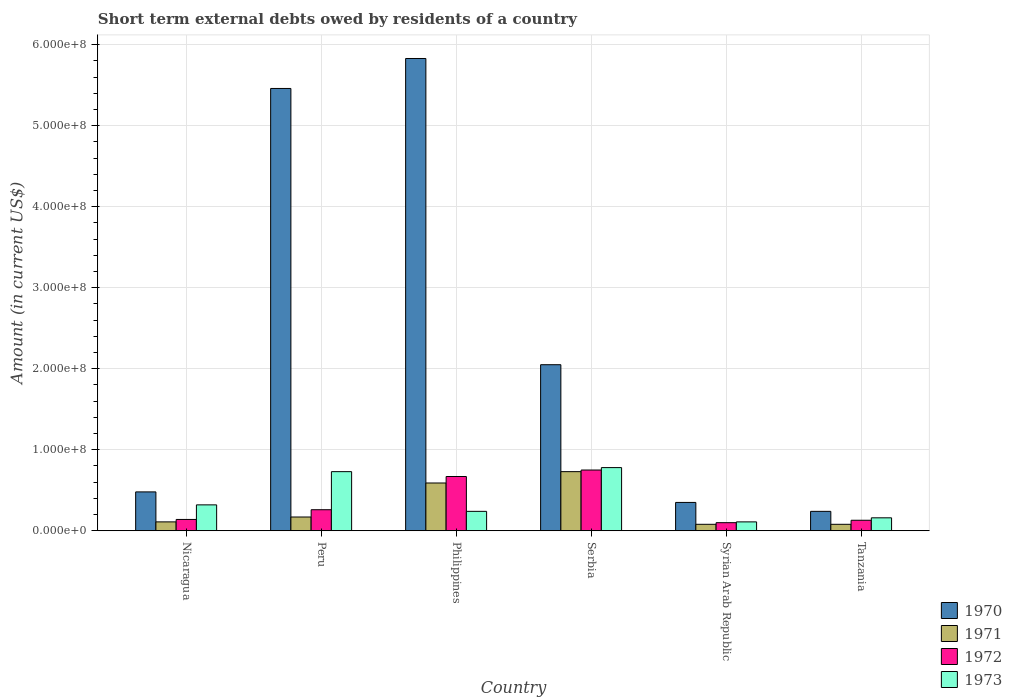How many groups of bars are there?
Keep it short and to the point. 6. Are the number of bars on each tick of the X-axis equal?
Your answer should be compact. Yes. How many bars are there on the 4th tick from the left?
Ensure brevity in your answer.  4. What is the label of the 6th group of bars from the left?
Keep it short and to the point. Tanzania. Across all countries, what is the maximum amount of short-term external debts owed by residents in 1972?
Provide a succinct answer. 7.50e+07. Across all countries, what is the minimum amount of short-term external debts owed by residents in 1973?
Your response must be concise. 1.10e+07. In which country was the amount of short-term external debts owed by residents in 1971 maximum?
Your answer should be very brief. Serbia. In which country was the amount of short-term external debts owed by residents in 1971 minimum?
Offer a very short reply. Syrian Arab Republic. What is the total amount of short-term external debts owed by residents in 1972 in the graph?
Your response must be concise. 2.05e+08. What is the difference between the amount of short-term external debts owed by residents in 1973 in Philippines and that in Serbia?
Ensure brevity in your answer.  -5.40e+07. What is the difference between the amount of short-term external debts owed by residents in 1970 in Nicaragua and the amount of short-term external debts owed by residents in 1971 in Tanzania?
Your answer should be very brief. 4.00e+07. What is the average amount of short-term external debts owed by residents in 1971 per country?
Give a very brief answer. 2.93e+07. What is the difference between the amount of short-term external debts owed by residents of/in 1971 and amount of short-term external debts owed by residents of/in 1972 in Nicaragua?
Make the answer very short. -3.00e+06. What is the ratio of the amount of short-term external debts owed by residents in 1973 in Philippines to that in Tanzania?
Offer a very short reply. 1.5. What is the difference between the highest and the second highest amount of short-term external debts owed by residents in 1972?
Your answer should be compact. 4.90e+07. What is the difference between the highest and the lowest amount of short-term external debts owed by residents in 1971?
Make the answer very short. 6.50e+07. In how many countries, is the amount of short-term external debts owed by residents in 1971 greater than the average amount of short-term external debts owed by residents in 1971 taken over all countries?
Your response must be concise. 2. What does the 3rd bar from the left in Tanzania represents?
Ensure brevity in your answer.  1972. How many bars are there?
Your answer should be very brief. 24. Are all the bars in the graph horizontal?
Offer a terse response. No. What is the difference between two consecutive major ticks on the Y-axis?
Give a very brief answer. 1.00e+08. Are the values on the major ticks of Y-axis written in scientific E-notation?
Keep it short and to the point. Yes. Does the graph contain any zero values?
Give a very brief answer. No. What is the title of the graph?
Provide a short and direct response. Short term external debts owed by residents of a country. Does "1979" appear as one of the legend labels in the graph?
Offer a very short reply. No. What is the label or title of the X-axis?
Offer a terse response. Country. What is the Amount (in current US$) in 1970 in Nicaragua?
Offer a terse response. 4.80e+07. What is the Amount (in current US$) of 1971 in Nicaragua?
Your response must be concise. 1.10e+07. What is the Amount (in current US$) of 1972 in Nicaragua?
Keep it short and to the point. 1.40e+07. What is the Amount (in current US$) of 1973 in Nicaragua?
Your answer should be very brief. 3.20e+07. What is the Amount (in current US$) in 1970 in Peru?
Keep it short and to the point. 5.46e+08. What is the Amount (in current US$) of 1971 in Peru?
Provide a succinct answer. 1.70e+07. What is the Amount (in current US$) of 1972 in Peru?
Provide a short and direct response. 2.60e+07. What is the Amount (in current US$) of 1973 in Peru?
Your answer should be very brief. 7.30e+07. What is the Amount (in current US$) in 1970 in Philippines?
Ensure brevity in your answer.  5.83e+08. What is the Amount (in current US$) in 1971 in Philippines?
Offer a terse response. 5.90e+07. What is the Amount (in current US$) of 1972 in Philippines?
Keep it short and to the point. 6.70e+07. What is the Amount (in current US$) of 1973 in Philippines?
Keep it short and to the point. 2.40e+07. What is the Amount (in current US$) in 1970 in Serbia?
Offer a very short reply. 2.05e+08. What is the Amount (in current US$) in 1971 in Serbia?
Give a very brief answer. 7.30e+07. What is the Amount (in current US$) of 1972 in Serbia?
Make the answer very short. 7.50e+07. What is the Amount (in current US$) of 1973 in Serbia?
Provide a succinct answer. 7.80e+07. What is the Amount (in current US$) of 1970 in Syrian Arab Republic?
Offer a terse response. 3.50e+07. What is the Amount (in current US$) of 1971 in Syrian Arab Republic?
Ensure brevity in your answer.  8.00e+06. What is the Amount (in current US$) in 1972 in Syrian Arab Republic?
Provide a short and direct response. 1.00e+07. What is the Amount (in current US$) in 1973 in Syrian Arab Republic?
Ensure brevity in your answer.  1.10e+07. What is the Amount (in current US$) in 1970 in Tanzania?
Your answer should be very brief. 2.40e+07. What is the Amount (in current US$) in 1971 in Tanzania?
Make the answer very short. 8.00e+06. What is the Amount (in current US$) of 1972 in Tanzania?
Offer a very short reply. 1.30e+07. What is the Amount (in current US$) of 1973 in Tanzania?
Offer a very short reply. 1.60e+07. Across all countries, what is the maximum Amount (in current US$) of 1970?
Your response must be concise. 5.83e+08. Across all countries, what is the maximum Amount (in current US$) in 1971?
Offer a terse response. 7.30e+07. Across all countries, what is the maximum Amount (in current US$) of 1972?
Make the answer very short. 7.50e+07. Across all countries, what is the maximum Amount (in current US$) in 1973?
Keep it short and to the point. 7.80e+07. Across all countries, what is the minimum Amount (in current US$) of 1970?
Give a very brief answer. 2.40e+07. Across all countries, what is the minimum Amount (in current US$) in 1973?
Offer a terse response. 1.10e+07. What is the total Amount (in current US$) in 1970 in the graph?
Your answer should be very brief. 1.44e+09. What is the total Amount (in current US$) in 1971 in the graph?
Make the answer very short. 1.76e+08. What is the total Amount (in current US$) of 1972 in the graph?
Offer a terse response. 2.05e+08. What is the total Amount (in current US$) of 1973 in the graph?
Offer a very short reply. 2.34e+08. What is the difference between the Amount (in current US$) in 1970 in Nicaragua and that in Peru?
Make the answer very short. -4.98e+08. What is the difference between the Amount (in current US$) of 1971 in Nicaragua and that in Peru?
Give a very brief answer. -6.00e+06. What is the difference between the Amount (in current US$) of 1972 in Nicaragua and that in Peru?
Offer a terse response. -1.20e+07. What is the difference between the Amount (in current US$) in 1973 in Nicaragua and that in Peru?
Provide a succinct answer. -4.10e+07. What is the difference between the Amount (in current US$) in 1970 in Nicaragua and that in Philippines?
Ensure brevity in your answer.  -5.35e+08. What is the difference between the Amount (in current US$) of 1971 in Nicaragua and that in Philippines?
Your answer should be compact. -4.80e+07. What is the difference between the Amount (in current US$) of 1972 in Nicaragua and that in Philippines?
Offer a terse response. -5.30e+07. What is the difference between the Amount (in current US$) in 1973 in Nicaragua and that in Philippines?
Ensure brevity in your answer.  8.00e+06. What is the difference between the Amount (in current US$) in 1970 in Nicaragua and that in Serbia?
Offer a terse response. -1.57e+08. What is the difference between the Amount (in current US$) in 1971 in Nicaragua and that in Serbia?
Your answer should be very brief. -6.20e+07. What is the difference between the Amount (in current US$) of 1972 in Nicaragua and that in Serbia?
Offer a very short reply. -6.10e+07. What is the difference between the Amount (in current US$) of 1973 in Nicaragua and that in Serbia?
Provide a succinct answer. -4.60e+07. What is the difference between the Amount (in current US$) of 1970 in Nicaragua and that in Syrian Arab Republic?
Your answer should be compact. 1.30e+07. What is the difference between the Amount (in current US$) in 1971 in Nicaragua and that in Syrian Arab Republic?
Offer a very short reply. 3.00e+06. What is the difference between the Amount (in current US$) in 1972 in Nicaragua and that in Syrian Arab Republic?
Provide a succinct answer. 4.00e+06. What is the difference between the Amount (in current US$) in 1973 in Nicaragua and that in Syrian Arab Republic?
Provide a short and direct response. 2.10e+07. What is the difference between the Amount (in current US$) in 1970 in Nicaragua and that in Tanzania?
Provide a short and direct response. 2.40e+07. What is the difference between the Amount (in current US$) in 1971 in Nicaragua and that in Tanzania?
Offer a very short reply. 3.00e+06. What is the difference between the Amount (in current US$) of 1973 in Nicaragua and that in Tanzania?
Your answer should be compact. 1.60e+07. What is the difference between the Amount (in current US$) in 1970 in Peru and that in Philippines?
Offer a very short reply. -3.70e+07. What is the difference between the Amount (in current US$) in 1971 in Peru and that in Philippines?
Your answer should be compact. -4.20e+07. What is the difference between the Amount (in current US$) of 1972 in Peru and that in Philippines?
Your response must be concise. -4.10e+07. What is the difference between the Amount (in current US$) of 1973 in Peru and that in Philippines?
Ensure brevity in your answer.  4.90e+07. What is the difference between the Amount (in current US$) in 1970 in Peru and that in Serbia?
Your response must be concise. 3.41e+08. What is the difference between the Amount (in current US$) in 1971 in Peru and that in Serbia?
Offer a terse response. -5.60e+07. What is the difference between the Amount (in current US$) of 1972 in Peru and that in Serbia?
Provide a short and direct response. -4.90e+07. What is the difference between the Amount (in current US$) of 1973 in Peru and that in Serbia?
Your response must be concise. -5.00e+06. What is the difference between the Amount (in current US$) in 1970 in Peru and that in Syrian Arab Republic?
Your answer should be very brief. 5.11e+08. What is the difference between the Amount (in current US$) in 1971 in Peru and that in Syrian Arab Republic?
Offer a very short reply. 9.00e+06. What is the difference between the Amount (in current US$) of 1972 in Peru and that in Syrian Arab Republic?
Your answer should be very brief. 1.60e+07. What is the difference between the Amount (in current US$) of 1973 in Peru and that in Syrian Arab Republic?
Provide a short and direct response. 6.20e+07. What is the difference between the Amount (in current US$) of 1970 in Peru and that in Tanzania?
Provide a succinct answer. 5.22e+08. What is the difference between the Amount (in current US$) of 1971 in Peru and that in Tanzania?
Your answer should be very brief. 9.00e+06. What is the difference between the Amount (in current US$) in 1972 in Peru and that in Tanzania?
Your response must be concise. 1.30e+07. What is the difference between the Amount (in current US$) of 1973 in Peru and that in Tanzania?
Keep it short and to the point. 5.70e+07. What is the difference between the Amount (in current US$) of 1970 in Philippines and that in Serbia?
Provide a short and direct response. 3.78e+08. What is the difference between the Amount (in current US$) of 1971 in Philippines and that in Serbia?
Provide a short and direct response. -1.40e+07. What is the difference between the Amount (in current US$) of 1972 in Philippines and that in Serbia?
Offer a terse response. -8.00e+06. What is the difference between the Amount (in current US$) in 1973 in Philippines and that in Serbia?
Give a very brief answer. -5.40e+07. What is the difference between the Amount (in current US$) of 1970 in Philippines and that in Syrian Arab Republic?
Provide a succinct answer. 5.48e+08. What is the difference between the Amount (in current US$) of 1971 in Philippines and that in Syrian Arab Republic?
Provide a short and direct response. 5.10e+07. What is the difference between the Amount (in current US$) in 1972 in Philippines and that in Syrian Arab Republic?
Offer a terse response. 5.70e+07. What is the difference between the Amount (in current US$) of 1973 in Philippines and that in Syrian Arab Republic?
Provide a succinct answer. 1.30e+07. What is the difference between the Amount (in current US$) of 1970 in Philippines and that in Tanzania?
Your answer should be very brief. 5.59e+08. What is the difference between the Amount (in current US$) in 1971 in Philippines and that in Tanzania?
Your response must be concise. 5.10e+07. What is the difference between the Amount (in current US$) in 1972 in Philippines and that in Tanzania?
Your response must be concise. 5.40e+07. What is the difference between the Amount (in current US$) of 1973 in Philippines and that in Tanzania?
Provide a succinct answer. 8.00e+06. What is the difference between the Amount (in current US$) of 1970 in Serbia and that in Syrian Arab Republic?
Your answer should be very brief. 1.70e+08. What is the difference between the Amount (in current US$) in 1971 in Serbia and that in Syrian Arab Republic?
Provide a short and direct response. 6.50e+07. What is the difference between the Amount (in current US$) in 1972 in Serbia and that in Syrian Arab Republic?
Keep it short and to the point. 6.50e+07. What is the difference between the Amount (in current US$) of 1973 in Serbia and that in Syrian Arab Republic?
Ensure brevity in your answer.  6.70e+07. What is the difference between the Amount (in current US$) of 1970 in Serbia and that in Tanzania?
Your response must be concise. 1.81e+08. What is the difference between the Amount (in current US$) of 1971 in Serbia and that in Tanzania?
Provide a succinct answer. 6.50e+07. What is the difference between the Amount (in current US$) in 1972 in Serbia and that in Tanzania?
Keep it short and to the point. 6.20e+07. What is the difference between the Amount (in current US$) of 1973 in Serbia and that in Tanzania?
Make the answer very short. 6.20e+07. What is the difference between the Amount (in current US$) of 1970 in Syrian Arab Republic and that in Tanzania?
Provide a short and direct response. 1.10e+07. What is the difference between the Amount (in current US$) of 1971 in Syrian Arab Republic and that in Tanzania?
Your response must be concise. 0. What is the difference between the Amount (in current US$) in 1972 in Syrian Arab Republic and that in Tanzania?
Keep it short and to the point. -3.00e+06. What is the difference between the Amount (in current US$) of 1973 in Syrian Arab Republic and that in Tanzania?
Your answer should be very brief. -5.00e+06. What is the difference between the Amount (in current US$) in 1970 in Nicaragua and the Amount (in current US$) in 1971 in Peru?
Your answer should be very brief. 3.10e+07. What is the difference between the Amount (in current US$) of 1970 in Nicaragua and the Amount (in current US$) of 1972 in Peru?
Keep it short and to the point. 2.20e+07. What is the difference between the Amount (in current US$) of 1970 in Nicaragua and the Amount (in current US$) of 1973 in Peru?
Ensure brevity in your answer.  -2.50e+07. What is the difference between the Amount (in current US$) of 1971 in Nicaragua and the Amount (in current US$) of 1972 in Peru?
Offer a very short reply. -1.50e+07. What is the difference between the Amount (in current US$) of 1971 in Nicaragua and the Amount (in current US$) of 1973 in Peru?
Give a very brief answer. -6.20e+07. What is the difference between the Amount (in current US$) in 1972 in Nicaragua and the Amount (in current US$) in 1973 in Peru?
Make the answer very short. -5.90e+07. What is the difference between the Amount (in current US$) in 1970 in Nicaragua and the Amount (in current US$) in 1971 in Philippines?
Your response must be concise. -1.10e+07. What is the difference between the Amount (in current US$) in 1970 in Nicaragua and the Amount (in current US$) in 1972 in Philippines?
Keep it short and to the point. -1.90e+07. What is the difference between the Amount (in current US$) of 1970 in Nicaragua and the Amount (in current US$) of 1973 in Philippines?
Offer a terse response. 2.40e+07. What is the difference between the Amount (in current US$) in 1971 in Nicaragua and the Amount (in current US$) in 1972 in Philippines?
Ensure brevity in your answer.  -5.60e+07. What is the difference between the Amount (in current US$) in 1971 in Nicaragua and the Amount (in current US$) in 1973 in Philippines?
Your answer should be compact. -1.30e+07. What is the difference between the Amount (in current US$) of 1972 in Nicaragua and the Amount (in current US$) of 1973 in Philippines?
Give a very brief answer. -1.00e+07. What is the difference between the Amount (in current US$) of 1970 in Nicaragua and the Amount (in current US$) of 1971 in Serbia?
Your answer should be compact. -2.50e+07. What is the difference between the Amount (in current US$) of 1970 in Nicaragua and the Amount (in current US$) of 1972 in Serbia?
Your response must be concise. -2.70e+07. What is the difference between the Amount (in current US$) in 1970 in Nicaragua and the Amount (in current US$) in 1973 in Serbia?
Ensure brevity in your answer.  -3.00e+07. What is the difference between the Amount (in current US$) of 1971 in Nicaragua and the Amount (in current US$) of 1972 in Serbia?
Make the answer very short. -6.40e+07. What is the difference between the Amount (in current US$) of 1971 in Nicaragua and the Amount (in current US$) of 1973 in Serbia?
Keep it short and to the point. -6.70e+07. What is the difference between the Amount (in current US$) in 1972 in Nicaragua and the Amount (in current US$) in 1973 in Serbia?
Ensure brevity in your answer.  -6.40e+07. What is the difference between the Amount (in current US$) in 1970 in Nicaragua and the Amount (in current US$) in 1971 in Syrian Arab Republic?
Provide a short and direct response. 4.00e+07. What is the difference between the Amount (in current US$) in 1970 in Nicaragua and the Amount (in current US$) in 1972 in Syrian Arab Republic?
Ensure brevity in your answer.  3.80e+07. What is the difference between the Amount (in current US$) of 1970 in Nicaragua and the Amount (in current US$) of 1973 in Syrian Arab Republic?
Provide a succinct answer. 3.70e+07. What is the difference between the Amount (in current US$) in 1971 in Nicaragua and the Amount (in current US$) in 1972 in Syrian Arab Republic?
Your response must be concise. 1.00e+06. What is the difference between the Amount (in current US$) of 1970 in Nicaragua and the Amount (in current US$) of 1971 in Tanzania?
Ensure brevity in your answer.  4.00e+07. What is the difference between the Amount (in current US$) of 1970 in Nicaragua and the Amount (in current US$) of 1972 in Tanzania?
Ensure brevity in your answer.  3.50e+07. What is the difference between the Amount (in current US$) of 1970 in Nicaragua and the Amount (in current US$) of 1973 in Tanzania?
Your answer should be very brief. 3.20e+07. What is the difference between the Amount (in current US$) of 1971 in Nicaragua and the Amount (in current US$) of 1973 in Tanzania?
Your answer should be very brief. -5.00e+06. What is the difference between the Amount (in current US$) in 1972 in Nicaragua and the Amount (in current US$) in 1973 in Tanzania?
Your response must be concise. -2.00e+06. What is the difference between the Amount (in current US$) in 1970 in Peru and the Amount (in current US$) in 1971 in Philippines?
Offer a terse response. 4.87e+08. What is the difference between the Amount (in current US$) in 1970 in Peru and the Amount (in current US$) in 1972 in Philippines?
Give a very brief answer. 4.79e+08. What is the difference between the Amount (in current US$) of 1970 in Peru and the Amount (in current US$) of 1973 in Philippines?
Ensure brevity in your answer.  5.22e+08. What is the difference between the Amount (in current US$) of 1971 in Peru and the Amount (in current US$) of 1972 in Philippines?
Make the answer very short. -5.00e+07. What is the difference between the Amount (in current US$) of 1971 in Peru and the Amount (in current US$) of 1973 in Philippines?
Give a very brief answer. -7.00e+06. What is the difference between the Amount (in current US$) in 1970 in Peru and the Amount (in current US$) in 1971 in Serbia?
Provide a succinct answer. 4.73e+08. What is the difference between the Amount (in current US$) in 1970 in Peru and the Amount (in current US$) in 1972 in Serbia?
Your answer should be compact. 4.71e+08. What is the difference between the Amount (in current US$) in 1970 in Peru and the Amount (in current US$) in 1973 in Serbia?
Provide a succinct answer. 4.68e+08. What is the difference between the Amount (in current US$) in 1971 in Peru and the Amount (in current US$) in 1972 in Serbia?
Provide a succinct answer. -5.80e+07. What is the difference between the Amount (in current US$) in 1971 in Peru and the Amount (in current US$) in 1973 in Serbia?
Provide a succinct answer. -6.10e+07. What is the difference between the Amount (in current US$) in 1972 in Peru and the Amount (in current US$) in 1973 in Serbia?
Offer a terse response. -5.20e+07. What is the difference between the Amount (in current US$) of 1970 in Peru and the Amount (in current US$) of 1971 in Syrian Arab Republic?
Provide a short and direct response. 5.38e+08. What is the difference between the Amount (in current US$) in 1970 in Peru and the Amount (in current US$) in 1972 in Syrian Arab Republic?
Your response must be concise. 5.36e+08. What is the difference between the Amount (in current US$) of 1970 in Peru and the Amount (in current US$) of 1973 in Syrian Arab Republic?
Provide a short and direct response. 5.35e+08. What is the difference between the Amount (in current US$) of 1972 in Peru and the Amount (in current US$) of 1973 in Syrian Arab Republic?
Ensure brevity in your answer.  1.50e+07. What is the difference between the Amount (in current US$) of 1970 in Peru and the Amount (in current US$) of 1971 in Tanzania?
Keep it short and to the point. 5.38e+08. What is the difference between the Amount (in current US$) of 1970 in Peru and the Amount (in current US$) of 1972 in Tanzania?
Your answer should be very brief. 5.33e+08. What is the difference between the Amount (in current US$) of 1970 in Peru and the Amount (in current US$) of 1973 in Tanzania?
Your answer should be compact. 5.30e+08. What is the difference between the Amount (in current US$) in 1971 in Peru and the Amount (in current US$) in 1972 in Tanzania?
Offer a terse response. 4.00e+06. What is the difference between the Amount (in current US$) in 1971 in Peru and the Amount (in current US$) in 1973 in Tanzania?
Keep it short and to the point. 1.00e+06. What is the difference between the Amount (in current US$) in 1970 in Philippines and the Amount (in current US$) in 1971 in Serbia?
Ensure brevity in your answer.  5.10e+08. What is the difference between the Amount (in current US$) of 1970 in Philippines and the Amount (in current US$) of 1972 in Serbia?
Provide a short and direct response. 5.08e+08. What is the difference between the Amount (in current US$) in 1970 in Philippines and the Amount (in current US$) in 1973 in Serbia?
Provide a short and direct response. 5.05e+08. What is the difference between the Amount (in current US$) in 1971 in Philippines and the Amount (in current US$) in 1972 in Serbia?
Ensure brevity in your answer.  -1.60e+07. What is the difference between the Amount (in current US$) of 1971 in Philippines and the Amount (in current US$) of 1973 in Serbia?
Offer a terse response. -1.90e+07. What is the difference between the Amount (in current US$) of 1972 in Philippines and the Amount (in current US$) of 1973 in Serbia?
Keep it short and to the point. -1.10e+07. What is the difference between the Amount (in current US$) of 1970 in Philippines and the Amount (in current US$) of 1971 in Syrian Arab Republic?
Offer a terse response. 5.75e+08. What is the difference between the Amount (in current US$) in 1970 in Philippines and the Amount (in current US$) in 1972 in Syrian Arab Republic?
Offer a very short reply. 5.73e+08. What is the difference between the Amount (in current US$) in 1970 in Philippines and the Amount (in current US$) in 1973 in Syrian Arab Republic?
Provide a succinct answer. 5.72e+08. What is the difference between the Amount (in current US$) in 1971 in Philippines and the Amount (in current US$) in 1972 in Syrian Arab Republic?
Keep it short and to the point. 4.90e+07. What is the difference between the Amount (in current US$) of 1971 in Philippines and the Amount (in current US$) of 1973 in Syrian Arab Republic?
Give a very brief answer. 4.80e+07. What is the difference between the Amount (in current US$) of 1972 in Philippines and the Amount (in current US$) of 1973 in Syrian Arab Republic?
Provide a short and direct response. 5.60e+07. What is the difference between the Amount (in current US$) in 1970 in Philippines and the Amount (in current US$) in 1971 in Tanzania?
Your answer should be very brief. 5.75e+08. What is the difference between the Amount (in current US$) in 1970 in Philippines and the Amount (in current US$) in 1972 in Tanzania?
Keep it short and to the point. 5.70e+08. What is the difference between the Amount (in current US$) of 1970 in Philippines and the Amount (in current US$) of 1973 in Tanzania?
Ensure brevity in your answer.  5.67e+08. What is the difference between the Amount (in current US$) of 1971 in Philippines and the Amount (in current US$) of 1972 in Tanzania?
Offer a very short reply. 4.60e+07. What is the difference between the Amount (in current US$) in 1971 in Philippines and the Amount (in current US$) in 1973 in Tanzania?
Your answer should be very brief. 4.30e+07. What is the difference between the Amount (in current US$) in 1972 in Philippines and the Amount (in current US$) in 1973 in Tanzania?
Keep it short and to the point. 5.10e+07. What is the difference between the Amount (in current US$) of 1970 in Serbia and the Amount (in current US$) of 1971 in Syrian Arab Republic?
Provide a succinct answer. 1.97e+08. What is the difference between the Amount (in current US$) of 1970 in Serbia and the Amount (in current US$) of 1972 in Syrian Arab Republic?
Provide a succinct answer. 1.95e+08. What is the difference between the Amount (in current US$) of 1970 in Serbia and the Amount (in current US$) of 1973 in Syrian Arab Republic?
Offer a very short reply. 1.94e+08. What is the difference between the Amount (in current US$) in 1971 in Serbia and the Amount (in current US$) in 1972 in Syrian Arab Republic?
Provide a short and direct response. 6.30e+07. What is the difference between the Amount (in current US$) in 1971 in Serbia and the Amount (in current US$) in 1973 in Syrian Arab Republic?
Give a very brief answer. 6.20e+07. What is the difference between the Amount (in current US$) of 1972 in Serbia and the Amount (in current US$) of 1973 in Syrian Arab Republic?
Your answer should be very brief. 6.40e+07. What is the difference between the Amount (in current US$) in 1970 in Serbia and the Amount (in current US$) in 1971 in Tanzania?
Keep it short and to the point. 1.97e+08. What is the difference between the Amount (in current US$) in 1970 in Serbia and the Amount (in current US$) in 1972 in Tanzania?
Ensure brevity in your answer.  1.92e+08. What is the difference between the Amount (in current US$) of 1970 in Serbia and the Amount (in current US$) of 1973 in Tanzania?
Your response must be concise. 1.89e+08. What is the difference between the Amount (in current US$) in 1971 in Serbia and the Amount (in current US$) in 1972 in Tanzania?
Keep it short and to the point. 6.00e+07. What is the difference between the Amount (in current US$) of 1971 in Serbia and the Amount (in current US$) of 1973 in Tanzania?
Ensure brevity in your answer.  5.70e+07. What is the difference between the Amount (in current US$) in 1972 in Serbia and the Amount (in current US$) in 1973 in Tanzania?
Offer a very short reply. 5.90e+07. What is the difference between the Amount (in current US$) in 1970 in Syrian Arab Republic and the Amount (in current US$) in 1971 in Tanzania?
Provide a short and direct response. 2.70e+07. What is the difference between the Amount (in current US$) of 1970 in Syrian Arab Republic and the Amount (in current US$) of 1972 in Tanzania?
Provide a short and direct response. 2.20e+07. What is the difference between the Amount (in current US$) of 1970 in Syrian Arab Republic and the Amount (in current US$) of 1973 in Tanzania?
Offer a terse response. 1.90e+07. What is the difference between the Amount (in current US$) of 1971 in Syrian Arab Republic and the Amount (in current US$) of 1972 in Tanzania?
Offer a terse response. -5.00e+06. What is the difference between the Amount (in current US$) in 1971 in Syrian Arab Republic and the Amount (in current US$) in 1973 in Tanzania?
Provide a short and direct response. -8.00e+06. What is the difference between the Amount (in current US$) in 1972 in Syrian Arab Republic and the Amount (in current US$) in 1973 in Tanzania?
Ensure brevity in your answer.  -6.00e+06. What is the average Amount (in current US$) of 1970 per country?
Provide a succinct answer. 2.40e+08. What is the average Amount (in current US$) of 1971 per country?
Keep it short and to the point. 2.93e+07. What is the average Amount (in current US$) of 1972 per country?
Your response must be concise. 3.42e+07. What is the average Amount (in current US$) in 1973 per country?
Provide a succinct answer. 3.90e+07. What is the difference between the Amount (in current US$) in 1970 and Amount (in current US$) in 1971 in Nicaragua?
Make the answer very short. 3.70e+07. What is the difference between the Amount (in current US$) of 1970 and Amount (in current US$) of 1972 in Nicaragua?
Your answer should be compact. 3.40e+07. What is the difference between the Amount (in current US$) in 1970 and Amount (in current US$) in 1973 in Nicaragua?
Your response must be concise. 1.60e+07. What is the difference between the Amount (in current US$) of 1971 and Amount (in current US$) of 1972 in Nicaragua?
Offer a very short reply. -3.00e+06. What is the difference between the Amount (in current US$) in 1971 and Amount (in current US$) in 1973 in Nicaragua?
Provide a short and direct response. -2.10e+07. What is the difference between the Amount (in current US$) in 1972 and Amount (in current US$) in 1973 in Nicaragua?
Your answer should be compact. -1.80e+07. What is the difference between the Amount (in current US$) in 1970 and Amount (in current US$) in 1971 in Peru?
Provide a succinct answer. 5.29e+08. What is the difference between the Amount (in current US$) of 1970 and Amount (in current US$) of 1972 in Peru?
Offer a terse response. 5.20e+08. What is the difference between the Amount (in current US$) in 1970 and Amount (in current US$) in 1973 in Peru?
Offer a very short reply. 4.73e+08. What is the difference between the Amount (in current US$) of 1971 and Amount (in current US$) of 1972 in Peru?
Offer a terse response. -9.00e+06. What is the difference between the Amount (in current US$) of 1971 and Amount (in current US$) of 1973 in Peru?
Make the answer very short. -5.60e+07. What is the difference between the Amount (in current US$) of 1972 and Amount (in current US$) of 1973 in Peru?
Ensure brevity in your answer.  -4.70e+07. What is the difference between the Amount (in current US$) of 1970 and Amount (in current US$) of 1971 in Philippines?
Make the answer very short. 5.24e+08. What is the difference between the Amount (in current US$) of 1970 and Amount (in current US$) of 1972 in Philippines?
Ensure brevity in your answer.  5.16e+08. What is the difference between the Amount (in current US$) of 1970 and Amount (in current US$) of 1973 in Philippines?
Your response must be concise. 5.59e+08. What is the difference between the Amount (in current US$) of 1971 and Amount (in current US$) of 1972 in Philippines?
Your answer should be compact. -8.00e+06. What is the difference between the Amount (in current US$) of 1971 and Amount (in current US$) of 1973 in Philippines?
Your answer should be compact. 3.50e+07. What is the difference between the Amount (in current US$) in 1972 and Amount (in current US$) in 1973 in Philippines?
Your response must be concise. 4.30e+07. What is the difference between the Amount (in current US$) of 1970 and Amount (in current US$) of 1971 in Serbia?
Your answer should be very brief. 1.32e+08. What is the difference between the Amount (in current US$) in 1970 and Amount (in current US$) in 1972 in Serbia?
Make the answer very short. 1.30e+08. What is the difference between the Amount (in current US$) in 1970 and Amount (in current US$) in 1973 in Serbia?
Your answer should be very brief. 1.27e+08. What is the difference between the Amount (in current US$) in 1971 and Amount (in current US$) in 1972 in Serbia?
Offer a terse response. -2.00e+06. What is the difference between the Amount (in current US$) of 1971 and Amount (in current US$) of 1973 in Serbia?
Your answer should be very brief. -5.00e+06. What is the difference between the Amount (in current US$) of 1972 and Amount (in current US$) of 1973 in Serbia?
Your response must be concise. -3.00e+06. What is the difference between the Amount (in current US$) in 1970 and Amount (in current US$) in 1971 in Syrian Arab Republic?
Provide a short and direct response. 2.70e+07. What is the difference between the Amount (in current US$) in 1970 and Amount (in current US$) in 1972 in Syrian Arab Republic?
Keep it short and to the point. 2.50e+07. What is the difference between the Amount (in current US$) in 1970 and Amount (in current US$) in 1973 in Syrian Arab Republic?
Give a very brief answer. 2.40e+07. What is the difference between the Amount (in current US$) of 1970 and Amount (in current US$) of 1971 in Tanzania?
Offer a terse response. 1.60e+07. What is the difference between the Amount (in current US$) of 1970 and Amount (in current US$) of 1972 in Tanzania?
Give a very brief answer. 1.10e+07. What is the difference between the Amount (in current US$) of 1971 and Amount (in current US$) of 1972 in Tanzania?
Offer a terse response. -5.00e+06. What is the difference between the Amount (in current US$) in 1971 and Amount (in current US$) in 1973 in Tanzania?
Ensure brevity in your answer.  -8.00e+06. What is the ratio of the Amount (in current US$) in 1970 in Nicaragua to that in Peru?
Offer a terse response. 0.09. What is the ratio of the Amount (in current US$) in 1971 in Nicaragua to that in Peru?
Offer a very short reply. 0.65. What is the ratio of the Amount (in current US$) in 1972 in Nicaragua to that in Peru?
Your answer should be compact. 0.54. What is the ratio of the Amount (in current US$) of 1973 in Nicaragua to that in Peru?
Provide a succinct answer. 0.44. What is the ratio of the Amount (in current US$) in 1970 in Nicaragua to that in Philippines?
Your answer should be very brief. 0.08. What is the ratio of the Amount (in current US$) in 1971 in Nicaragua to that in Philippines?
Offer a very short reply. 0.19. What is the ratio of the Amount (in current US$) of 1972 in Nicaragua to that in Philippines?
Your answer should be very brief. 0.21. What is the ratio of the Amount (in current US$) in 1970 in Nicaragua to that in Serbia?
Provide a succinct answer. 0.23. What is the ratio of the Amount (in current US$) in 1971 in Nicaragua to that in Serbia?
Ensure brevity in your answer.  0.15. What is the ratio of the Amount (in current US$) in 1972 in Nicaragua to that in Serbia?
Offer a very short reply. 0.19. What is the ratio of the Amount (in current US$) in 1973 in Nicaragua to that in Serbia?
Offer a terse response. 0.41. What is the ratio of the Amount (in current US$) of 1970 in Nicaragua to that in Syrian Arab Republic?
Keep it short and to the point. 1.37. What is the ratio of the Amount (in current US$) in 1971 in Nicaragua to that in Syrian Arab Republic?
Provide a short and direct response. 1.38. What is the ratio of the Amount (in current US$) in 1973 in Nicaragua to that in Syrian Arab Republic?
Your response must be concise. 2.91. What is the ratio of the Amount (in current US$) of 1970 in Nicaragua to that in Tanzania?
Your answer should be compact. 2. What is the ratio of the Amount (in current US$) in 1971 in Nicaragua to that in Tanzania?
Your answer should be compact. 1.38. What is the ratio of the Amount (in current US$) of 1972 in Nicaragua to that in Tanzania?
Make the answer very short. 1.08. What is the ratio of the Amount (in current US$) in 1970 in Peru to that in Philippines?
Your response must be concise. 0.94. What is the ratio of the Amount (in current US$) of 1971 in Peru to that in Philippines?
Provide a succinct answer. 0.29. What is the ratio of the Amount (in current US$) in 1972 in Peru to that in Philippines?
Your answer should be compact. 0.39. What is the ratio of the Amount (in current US$) in 1973 in Peru to that in Philippines?
Ensure brevity in your answer.  3.04. What is the ratio of the Amount (in current US$) of 1970 in Peru to that in Serbia?
Your answer should be very brief. 2.66. What is the ratio of the Amount (in current US$) in 1971 in Peru to that in Serbia?
Your answer should be very brief. 0.23. What is the ratio of the Amount (in current US$) in 1972 in Peru to that in Serbia?
Your answer should be compact. 0.35. What is the ratio of the Amount (in current US$) of 1973 in Peru to that in Serbia?
Offer a very short reply. 0.94. What is the ratio of the Amount (in current US$) in 1971 in Peru to that in Syrian Arab Republic?
Provide a succinct answer. 2.12. What is the ratio of the Amount (in current US$) in 1972 in Peru to that in Syrian Arab Republic?
Give a very brief answer. 2.6. What is the ratio of the Amount (in current US$) of 1973 in Peru to that in Syrian Arab Republic?
Ensure brevity in your answer.  6.64. What is the ratio of the Amount (in current US$) of 1970 in Peru to that in Tanzania?
Ensure brevity in your answer.  22.75. What is the ratio of the Amount (in current US$) in 1971 in Peru to that in Tanzania?
Offer a very short reply. 2.12. What is the ratio of the Amount (in current US$) in 1972 in Peru to that in Tanzania?
Give a very brief answer. 2. What is the ratio of the Amount (in current US$) of 1973 in Peru to that in Tanzania?
Your answer should be very brief. 4.56. What is the ratio of the Amount (in current US$) in 1970 in Philippines to that in Serbia?
Make the answer very short. 2.84. What is the ratio of the Amount (in current US$) of 1971 in Philippines to that in Serbia?
Provide a succinct answer. 0.81. What is the ratio of the Amount (in current US$) of 1972 in Philippines to that in Serbia?
Ensure brevity in your answer.  0.89. What is the ratio of the Amount (in current US$) of 1973 in Philippines to that in Serbia?
Keep it short and to the point. 0.31. What is the ratio of the Amount (in current US$) in 1970 in Philippines to that in Syrian Arab Republic?
Offer a terse response. 16.66. What is the ratio of the Amount (in current US$) in 1971 in Philippines to that in Syrian Arab Republic?
Keep it short and to the point. 7.38. What is the ratio of the Amount (in current US$) in 1972 in Philippines to that in Syrian Arab Republic?
Offer a very short reply. 6.7. What is the ratio of the Amount (in current US$) in 1973 in Philippines to that in Syrian Arab Republic?
Ensure brevity in your answer.  2.18. What is the ratio of the Amount (in current US$) in 1970 in Philippines to that in Tanzania?
Offer a very short reply. 24.29. What is the ratio of the Amount (in current US$) of 1971 in Philippines to that in Tanzania?
Offer a terse response. 7.38. What is the ratio of the Amount (in current US$) in 1972 in Philippines to that in Tanzania?
Give a very brief answer. 5.15. What is the ratio of the Amount (in current US$) of 1973 in Philippines to that in Tanzania?
Your answer should be compact. 1.5. What is the ratio of the Amount (in current US$) in 1970 in Serbia to that in Syrian Arab Republic?
Offer a very short reply. 5.86. What is the ratio of the Amount (in current US$) of 1971 in Serbia to that in Syrian Arab Republic?
Keep it short and to the point. 9.12. What is the ratio of the Amount (in current US$) in 1972 in Serbia to that in Syrian Arab Republic?
Your response must be concise. 7.5. What is the ratio of the Amount (in current US$) in 1973 in Serbia to that in Syrian Arab Republic?
Your answer should be compact. 7.09. What is the ratio of the Amount (in current US$) in 1970 in Serbia to that in Tanzania?
Your response must be concise. 8.54. What is the ratio of the Amount (in current US$) in 1971 in Serbia to that in Tanzania?
Provide a short and direct response. 9.12. What is the ratio of the Amount (in current US$) in 1972 in Serbia to that in Tanzania?
Your answer should be compact. 5.77. What is the ratio of the Amount (in current US$) of 1973 in Serbia to that in Tanzania?
Offer a terse response. 4.88. What is the ratio of the Amount (in current US$) in 1970 in Syrian Arab Republic to that in Tanzania?
Offer a terse response. 1.46. What is the ratio of the Amount (in current US$) of 1971 in Syrian Arab Republic to that in Tanzania?
Make the answer very short. 1. What is the ratio of the Amount (in current US$) in 1972 in Syrian Arab Republic to that in Tanzania?
Offer a very short reply. 0.77. What is the ratio of the Amount (in current US$) of 1973 in Syrian Arab Republic to that in Tanzania?
Give a very brief answer. 0.69. What is the difference between the highest and the second highest Amount (in current US$) in 1970?
Ensure brevity in your answer.  3.70e+07. What is the difference between the highest and the second highest Amount (in current US$) of 1971?
Offer a terse response. 1.40e+07. What is the difference between the highest and the lowest Amount (in current US$) of 1970?
Keep it short and to the point. 5.59e+08. What is the difference between the highest and the lowest Amount (in current US$) of 1971?
Provide a short and direct response. 6.50e+07. What is the difference between the highest and the lowest Amount (in current US$) of 1972?
Provide a short and direct response. 6.50e+07. What is the difference between the highest and the lowest Amount (in current US$) of 1973?
Your answer should be very brief. 6.70e+07. 